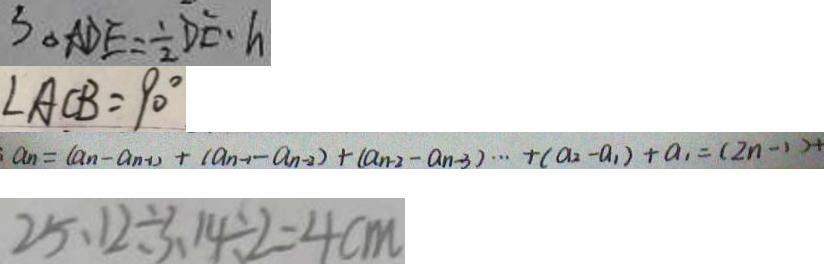<formula> <loc_0><loc_0><loc_500><loc_500>S _ { \Delta A D E } = \frac { 1 } { 2 } D E \cdot h 
 \angle A C B = 9 0 ^ { \circ } 
 : a _ { n } = ( a _ { n } - a _ { n - 1 } ) + ( a _ { n - 1 } - a _ { n - 2 } ) + ( a _ { n - 2 } - a _ { n - 3 } ) \cdots + ( a _ { 2 } - a _ { 1 } ) + a _ { 1 } = ( 2 n - 1 ) + 
 2 5 . 1 2 \div 3 . 1 4 \div 2 = 4 c m</formula> 